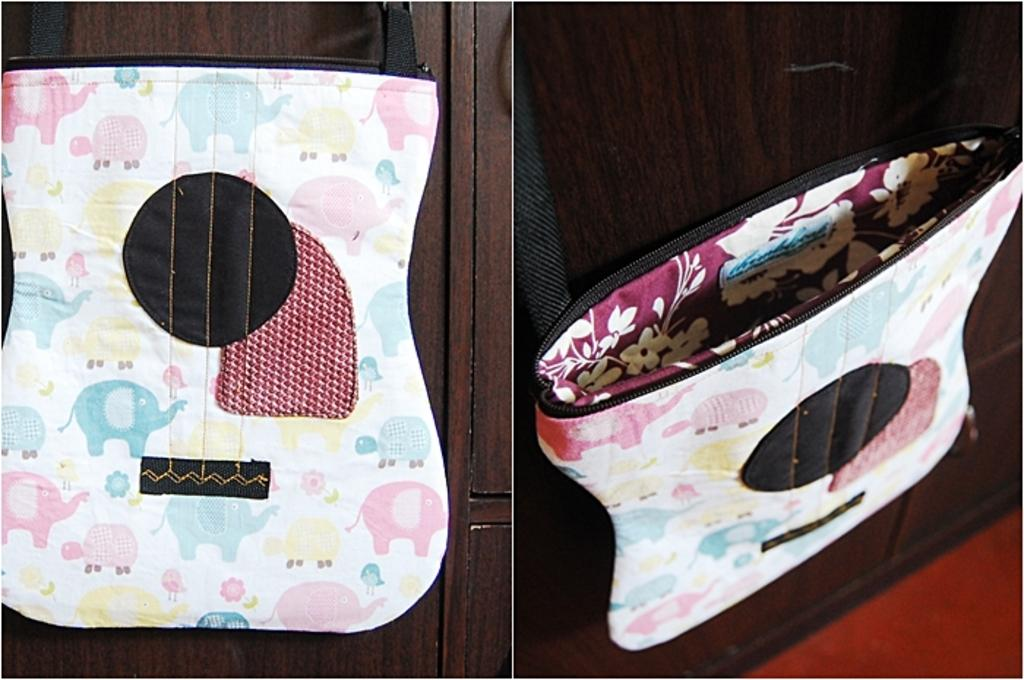What type of image is the collage in the picture? The image is a collage edit. How many images are combined in the collage? There are two images combined in the collage. What is happening in one of the images? One image shows a bag hanging. What does the other image resemble? The other image resembles a guitar. What type of skin condition can be seen on the guitar in the image? There is no skin condition present in the image, as it features a collage of a bag and a guitar. 